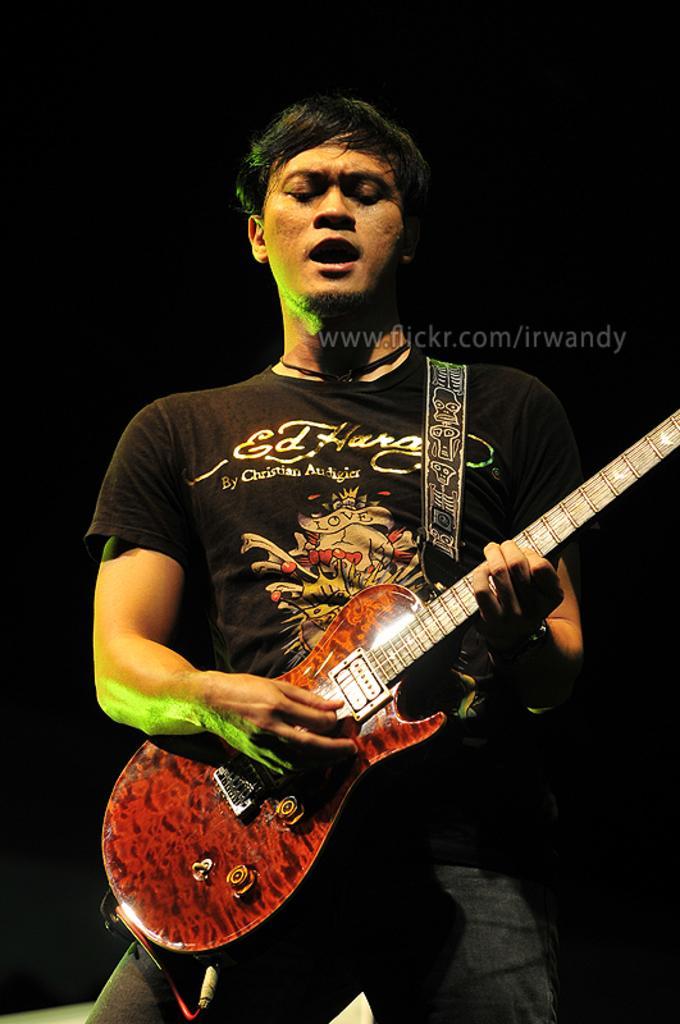In one or two sentences, can you explain what this image depicts? Here we can see a man standing and he is playing a guitar and he is also singing a song and this we can see by seeing his mouth 